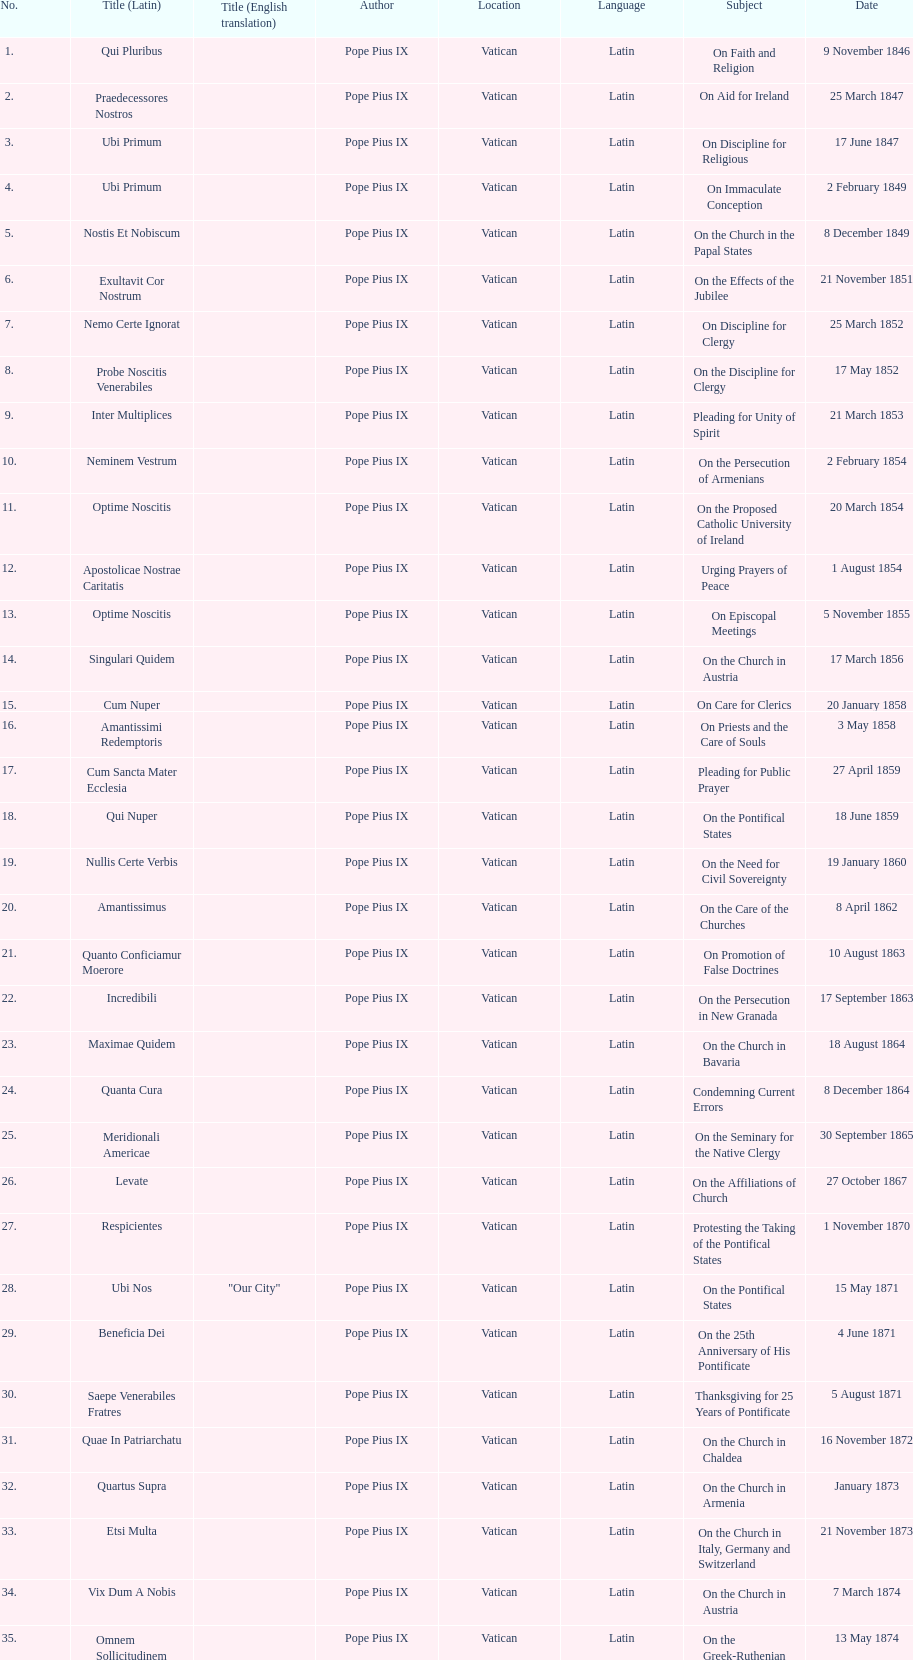How many subjects are there? 38. 